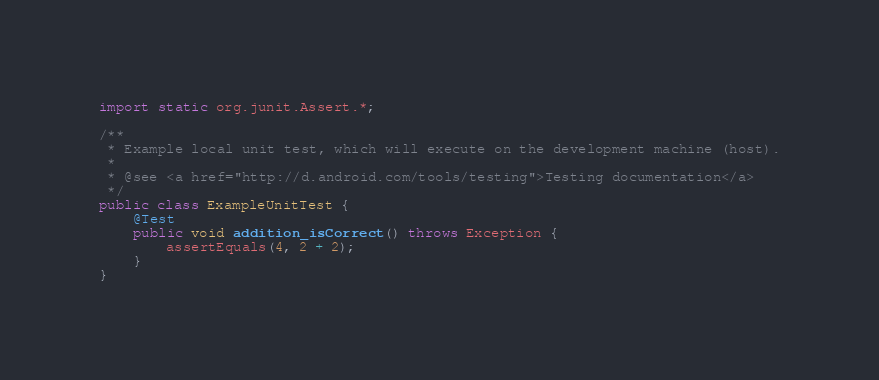Convert code to text. <code><loc_0><loc_0><loc_500><loc_500><_Java_>import static org.junit.Assert.*;

/**
 * Example local unit test, which will execute on the development machine (host).
 *
 * @see <a href="http://d.android.com/tools/testing">Testing documentation</a>
 */
public class ExampleUnitTest {
    @Test
    public void addition_isCorrect() throws Exception {
        assertEquals(4, 2 + 2);
    }
}</code> 